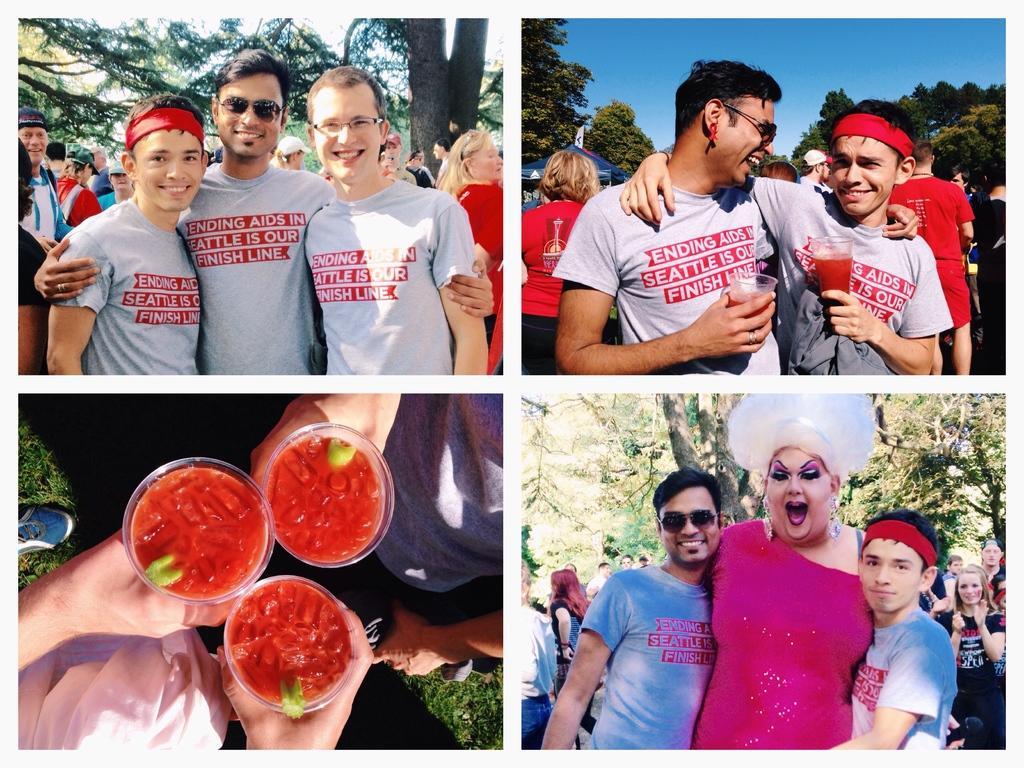In one or two sentences, can you explain what this image depicts? This is a collage image. In this I can see four pictures. In the left top of the image I can see three men are wearing same t-shirts, smiling and giving pose for the picture. In the background I can see the trees. In the right top of the image, two men are glasses in their hands and smiling by looking at each other. In the right bottom of the image I can see a woman and two boys are smiling and giving pose for the picture. In the background I can see the trees. In the left bottom of the image two person are holding three glasses in their hands. In the glasses I can see red color juice. 